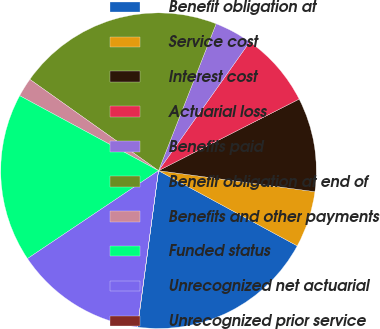Convert chart to OTSL. <chart><loc_0><loc_0><loc_500><loc_500><pie_chart><fcel>Benefit obligation at<fcel>Service cost<fcel>Interest cost<fcel>Actuarial loss<fcel>Benefits paid<fcel>Benefit obligation at end of<fcel>Benefits and other payments<fcel>Funded status<fcel>Unrecognized net actuarial<fcel>Unrecognized prior service<nl><fcel>19.21%<fcel>5.78%<fcel>9.62%<fcel>7.7%<fcel>3.86%<fcel>21.13%<fcel>1.94%<fcel>17.29%<fcel>13.46%<fcel>0.02%<nl></chart> 